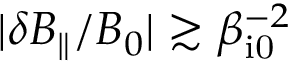<formula> <loc_0><loc_0><loc_500><loc_500>| \delta B _ { \| } / B _ { 0 } | \gtrsim \beta _ { i 0 } ^ { - 2 }</formula> 